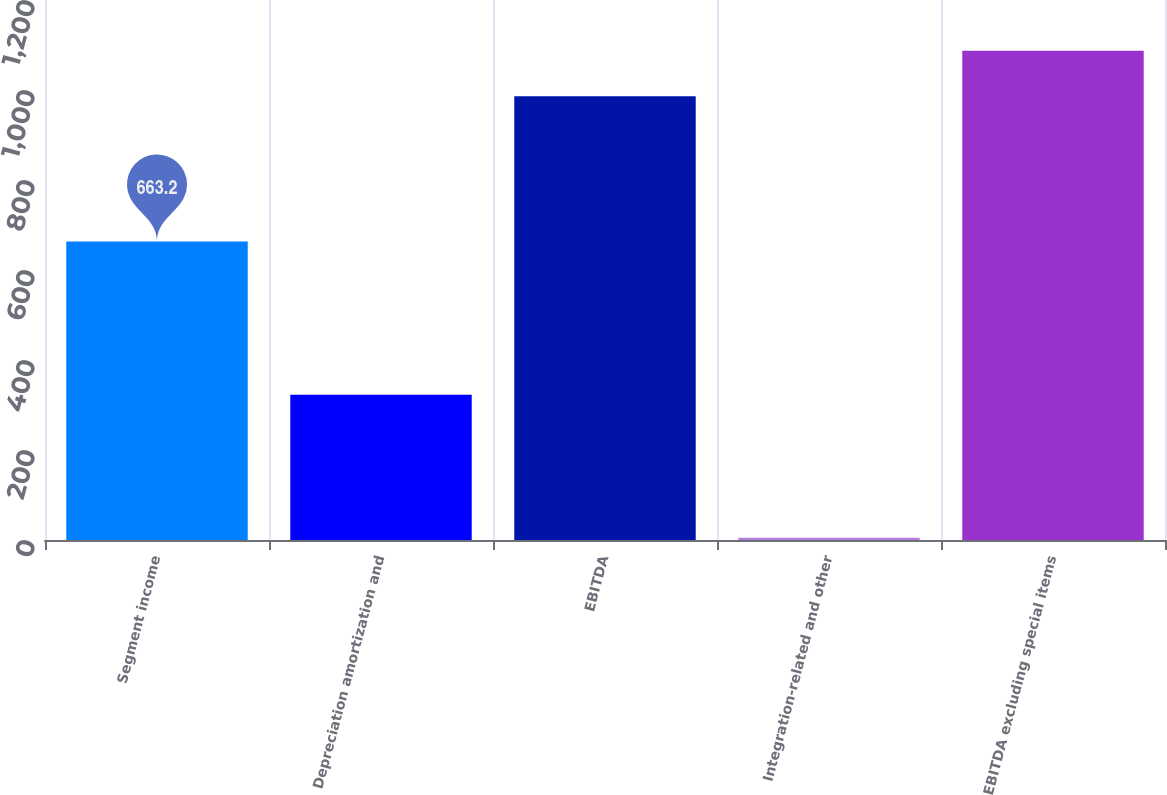Convert chart. <chart><loc_0><loc_0><loc_500><loc_500><bar_chart><fcel>Segment income<fcel>Depreciation amortization and<fcel>EBITDA<fcel>Integration-related and other<fcel>EBITDA excluding special items<nl><fcel>663.2<fcel>323<fcel>986.2<fcel>4.9<fcel>1087.21<nl></chart> 